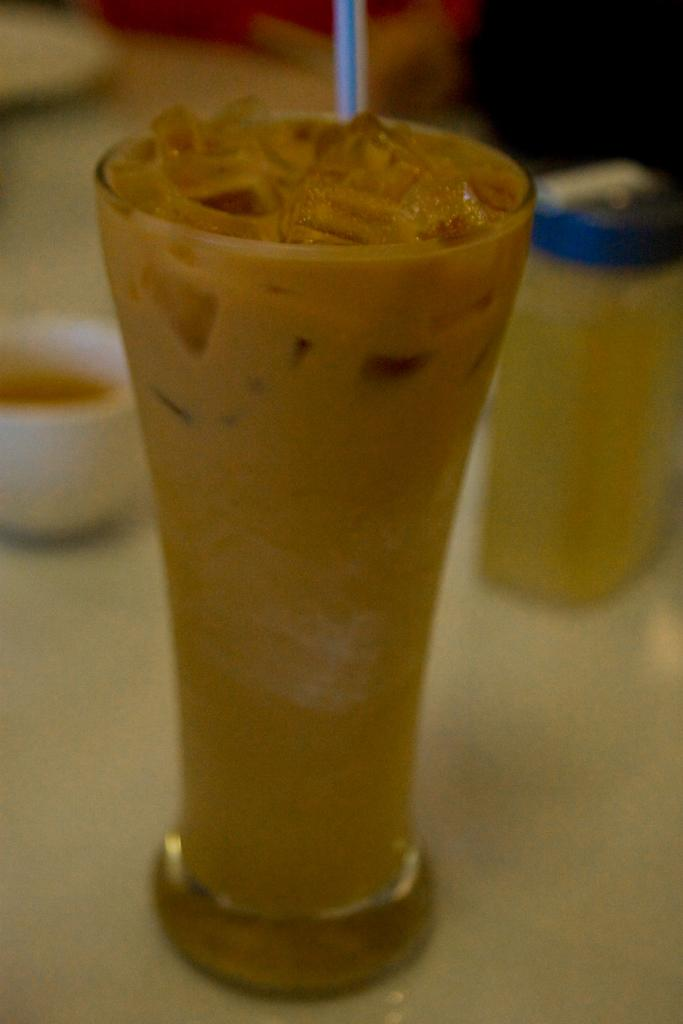What is on the surface in the image? There is a glass with a straw on the surface. What else can be seen on the surface? There is a cup on the surface. Are there any other containers in the image? Yes, there is a small bottle in the image. What type of tail can be seen on the page in the image? There is no page or tail present in the image. 